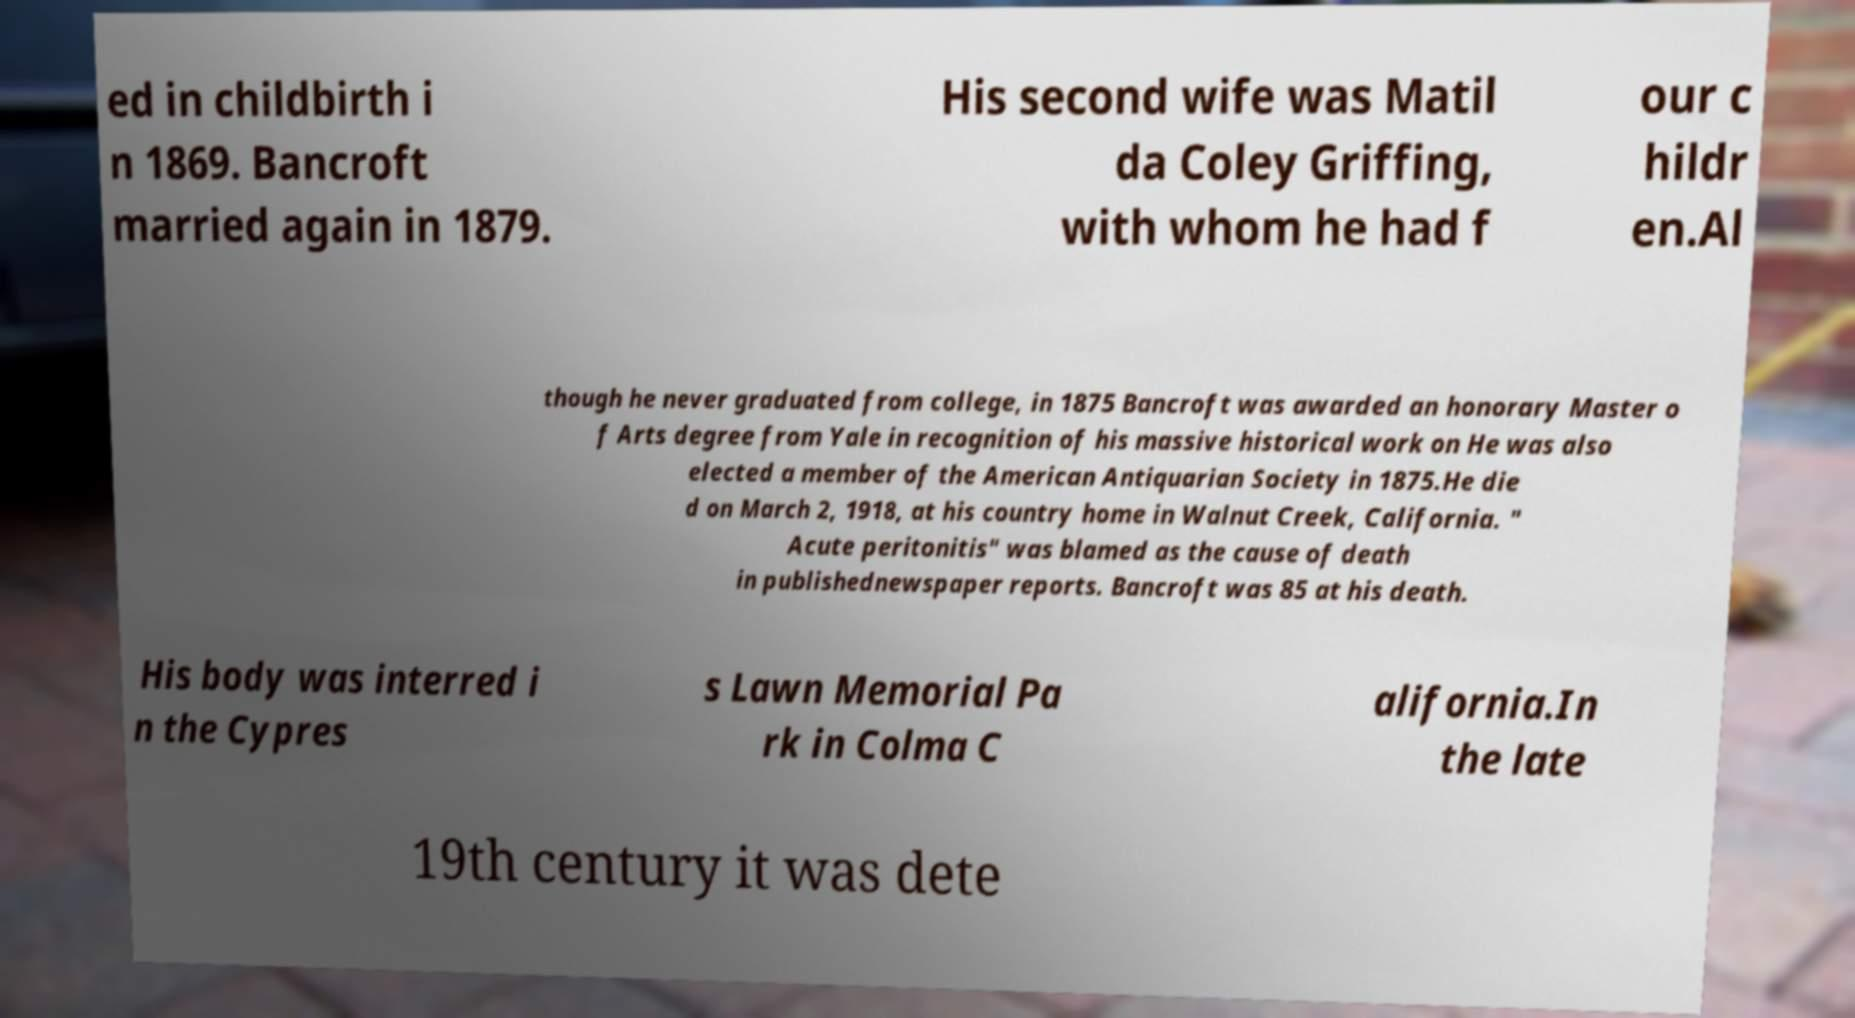Please read and relay the text visible in this image. What does it say? ed in childbirth i n 1869. Bancroft married again in 1879. His second wife was Matil da Coley Griffing, with whom he had f our c hildr en.Al though he never graduated from college, in 1875 Bancroft was awarded an honorary Master o f Arts degree from Yale in recognition of his massive historical work on He was also elected a member of the American Antiquarian Society in 1875.He die d on March 2, 1918, at his country home in Walnut Creek, California. " Acute peritonitis" was blamed as the cause of death in publishednewspaper reports. Bancroft was 85 at his death. His body was interred i n the Cypres s Lawn Memorial Pa rk in Colma C alifornia.In the late 19th century it was dete 